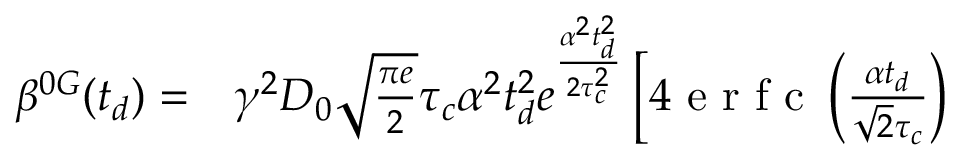Convert formula to latex. <formula><loc_0><loc_0><loc_500><loc_500>\begin{array} { r l } { \beta ^ { 0 G } ( t _ { d } ) = } & \gamma ^ { 2 } D _ { 0 } \sqrt { \frac { \pi e } { 2 } } \tau _ { c } \alpha ^ { 2 } t _ { d } ^ { 2 } e ^ { \frac { \alpha ^ { 2 } t _ { d } ^ { 2 } } { 2 \tau _ { c } ^ { 2 } } } \left [ 4 e r f c \left ( \frac { \alpha t _ { d } } { \sqrt { 2 } \tau _ { c } } \right ) } \end{array}</formula> 